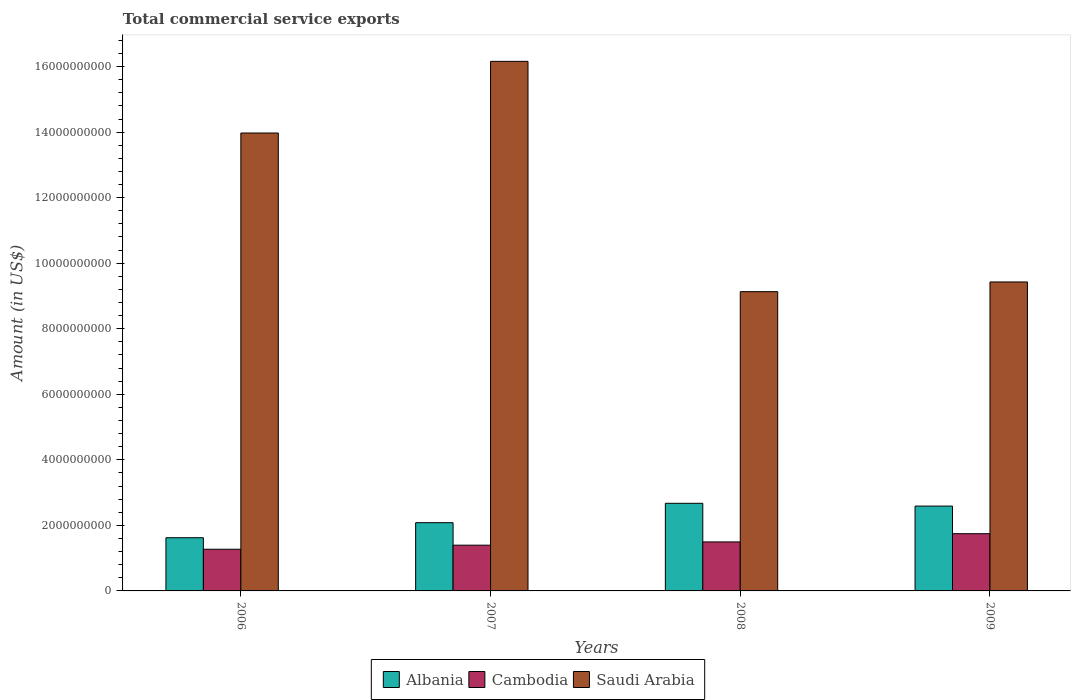Are the number of bars on each tick of the X-axis equal?
Ensure brevity in your answer.  Yes. How many bars are there on the 4th tick from the right?
Your answer should be compact. 3. What is the label of the 1st group of bars from the left?
Your response must be concise. 2006. What is the total commercial service exports in Albania in 2009?
Offer a terse response. 2.59e+09. Across all years, what is the maximum total commercial service exports in Albania?
Make the answer very short. 2.67e+09. Across all years, what is the minimum total commercial service exports in Albania?
Give a very brief answer. 1.62e+09. In which year was the total commercial service exports in Saudi Arabia minimum?
Make the answer very short. 2008. What is the total total commercial service exports in Albania in the graph?
Give a very brief answer. 8.97e+09. What is the difference between the total commercial service exports in Cambodia in 2007 and that in 2009?
Provide a short and direct response. -3.51e+08. What is the difference between the total commercial service exports in Saudi Arabia in 2008 and the total commercial service exports in Albania in 2009?
Offer a very short reply. 6.54e+09. What is the average total commercial service exports in Saudi Arabia per year?
Offer a very short reply. 1.22e+1. In the year 2006, what is the difference between the total commercial service exports in Albania and total commercial service exports in Saudi Arabia?
Your answer should be very brief. -1.24e+1. In how many years, is the total commercial service exports in Albania greater than 8400000000 US$?
Provide a succinct answer. 0. What is the ratio of the total commercial service exports in Albania in 2006 to that in 2008?
Provide a succinct answer. 0.61. What is the difference between the highest and the second highest total commercial service exports in Saudi Arabia?
Make the answer very short. 2.19e+09. What is the difference between the highest and the lowest total commercial service exports in Albania?
Ensure brevity in your answer.  1.05e+09. In how many years, is the total commercial service exports in Albania greater than the average total commercial service exports in Albania taken over all years?
Your answer should be very brief. 2. What does the 1st bar from the left in 2006 represents?
Make the answer very short. Albania. What does the 3rd bar from the right in 2008 represents?
Provide a succinct answer. Albania. Is it the case that in every year, the sum of the total commercial service exports in Albania and total commercial service exports in Cambodia is greater than the total commercial service exports in Saudi Arabia?
Your answer should be very brief. No. Are all the bars in the graph horizontal?
Provide a succinct answer. No. What is the difference between two consecutive major ticks on the Y-axis?
Keep it short and to the point. 2.00e+09. Does the graph contain any zero values?
Provide a succinct answer. No. Where does the legend appear in the graph?
Offer a terse response. Bottom center. How are the legend labels stacked?
Offer a very short reply. Horizontal. What is the title of the graph?
Give a very brief answer. Total commercial service exports. Does "Tunisia" appear as one of the legend labels in the graph?
Your response must be concise. No. What is the label or title of the X-axis?
Keep it short and to the point. Years. What is the label or title of the Y-axis?
Give a very brief answer. Amount (in US$). What is the Amount (in US$) in Albania in 2006?
Provide a short and direct response. 1.62e+09. What is the Amount (in US$) in Cambodia in 2006?
Provide a short and direct response. 1.27e+09. What is the Amount (in US$) in Saudi Arabia in 2006?
Offer a very short reply. 1.40e+1. What is the Amount (in US$) in Albania in 2007?
Give a very brief answer. 2.08e+09. What is the Amount (in US$) in Cambodia in 2007?
Provide a succinct answer. 1.40e+09. What is the Amount (in US$) of Saudi Arabia in 2007?
Your response must be concise. 1.62e+1. What is the Amount (in US$) of Albania in 2008?
Provide a short and direct response. 2.67e+09. What is the Amount (in US$) of Cambodia in 2008?
Keep it short and to the point. 1.49e+09. What is the Amount (in US$) in Saudi Arabia in 2008?
Keep it short and to the point. 9.13e+09. What is the Amount (in US$) of Albania in 2009?
Give a very brief answer. 2.59e+09. What is the Amount (in US$) of Cambodia in 2009?
Your answer should be compact. 1.75e+09. What is the Amount (in US$) in Saudi Arabia in 2009?
Your answer should be compact. 9.43e+09. Across all years, what is the maximum Amount (in US$) of Albania?
Ensure brevity in your answer.  2.67e+09. Across all years, what is the maximum Amount (in US$) of Cambodia?
Ensure brevity in your answer.  1.75e+09. Across all years, what is the maximum Amount (in US$) in Saudi Arabia?
Make the answer very short. 1.62e+1. Across all years, what is the minimum Amount (in US$) of Albania?
Keep it short and to the point. 1.62e+09. Across all years, what is the minimum Amount (in US$) in Cambodia?
Offer a terse response. 1.27e+09. Across all years, what is the minimum Amount (in US$) in Saudi Arabia?
Make the answer very short. 9.13e+09. What is the total Amount (in US$) in Albania in the graph?
Give a very brief answer. 8.97e+09. What is the total Amount (in US$) of Cambodia in the graph?
Offer a terse response. 5.91e+09. What is the total Amount (in US$) of Saudi Arabia in the graph?
Your answer should be very brief. 4.87e+1. What is the difference between the Amount (in US$) in Albania in 2006 and that in 2007?
Your response must be concise. -4.59e+08. What is the difference between the Amount (in US$) of Cambodia in 2006 and that in 2007?
Provide a succinct answer. -1.24e+08. What is the difference between the Amount (in US$) of Saudi Arabia in 2006 and that in 2007?
Your response must be concise. -2.19e+09. What is the difference between the Amount (in US$) in Albania in 2006 and that in 2008?
Provide a short and direct response. -1.05e+09. What is the difference between the Amount (in US$) of Cambodia in 2006 and that in 2008?
Your response must be concise. -2.23e+08. What is the difference between the Amount (in US$) in Saudi Arabia in 2006 and that in 2008?
Keep it short and to the point. 4.84e+09. What is the difference between the Amount (in US$) of Albania in 2006 and that in 2009?
Your answer should be very brief. -9.66e+08. What is the difference between the Amount (in US$) in Cambodia in 2006 and that in 2009?
Your response must be concise. -4.75e+08. What is the difference between the Amount (in US$) of Saudi Arabia in 2006 and that in 2009?
Give a very brief answer. 4.55e+09. What is the difference between the Amount (in US$) of Albania in 2007 and that in 2008?
Your answer should be compact. -5.91e+08. What is the difference between the Amount (in US$) of Cambodia in 2007 and that in 2008?
Your response must be concise. -9.91e+07. What is the difference between the Amount (in US$) of Saudi Arabia in 2007 and that in 2008?
Provide a short and direct response. 7.03e+09. What is the difference between the Amount (in US$) in Albania in 2007 and that in 2009?
Keep it short and to the point. -5.06e+08. What is the difference between the Amount (in US$) in Cambodia in 2007 and that in 2009?
Ensure brevity in your answer.  -3.51e+08. What is the difference between the Amount (in US$) of Saudi Arabia in 2007 and that in 2009?
Offer a very short reply. 6.73e+09. What is the difference between the Amount (in US$) in Albania in 2008 and that in 2009?
Your response must be concise. 8.51e+07. What is the difference between the Amount (in US$) of Cambodia in 2008 and that in 2009?
Ensure brevity in your answer.  -2.52e+08. What is the difference between the Amount (in US$) in Saudi Arabia in 2008 and that in 2009?
Ensure brevity in your answer.  -2.96e+08. What is the difference between the Amount (in US$) in Albania in 2006 and the Amount (in US$) in Cambodia in 2007?
Your answer should be very brief. 2.27e+08. What is the difference between the Amount (in US$) of Albania in 2006 and the Amount (in US$) of Saudi Arabia in 2007?
Ensure brevity in your answer.  -1.45e+1. What is the difference between the Amount (in US$) of Cambodia in 2006 and the Amount (in US$) of Saudi Arabia in 2007?
Offer a terse response. -1.49e+1. What is the difference between the Amount (in US$) of Albania in 2006 and the Amount (in US$) of Cambodia in 2008?
Give a very brief answer. 1.28e+08. What is the difference between the Amount (in US$) of Albania in 2006 and the Amount (in US$) of Saudi Arabia in 2008?
Your answer should be compact. -7.51e+09. What is the difference between the Amount (in US$) of Cambodia in 2006 and the Amount (in US$) of Saudi Arabia in 2008?
Make the answer very short. -7.86e+09. What is the difference between the Amount (in US$) of Albania in 2006 and the Amount (in US$) of Cambodia in 2009?
Provide a short and direct response. -1.23e+08. What is the difference between the Amount (in US$) of Albania in 2006 and the Amount (in US$) of Saudi Arabia in 2009?
Your answer should be compact. -7.80e+09. What is the difference between the Amount (in US$) in Cambodia in 2006 and the Amount (in US$) in Saudi Arabia in 2009?
Offer a terse response. -8.16e+09. What is the difference between the Amount (in US$) of Albania in 2007 and the Amount (in US$) of Cambodia in 2008?
Provide a succinct answer. 5.88e+08. What is the difference between the Amount (in US$) in Albania in 2007 and the Amount (in US$) in Saudi Arabia in 2008?
Offer a very short reply. -7.05e+09. What is the difference between the Amount (in US$) of Cambodia in 2007 and the Amount (in US$) of Saudi Arabia in 2008?
Ensure brevity in your answer.  -7.74e+09. What is the difference between the Amount (in US$) of Albania in 2007 and the Amount (in US$) of Cambodia in 2009?
Provide a short and direct response. 3.36e+08. What is the difference between the Amount (in US$) of Albania in 2007 and the Amount (in US$) of Saudi Arabia in 2009?
Your answer should be very brief. -7.35e+09. What is the difference between the Amount (in US$) in Cambodia in 2007 and the Amount (in US$) in Saudi Arabia in 2009?
Offer a terse response. -8.03e+09. What is the difference between the Amount (in US$) of Albania in 2008 and the Amount (in US$) of Cambodia in 2009?
Provide a succinct answer. 9.27e+08. What is the difference between the Amount (in US$) of Albania in 2008 and the Amount (in US$) of Saudi Arabia in 2009?
Give a very brief answer. -6.75e+09. What is the difference between the Amount (in US$) in Cambodia in 2008 and the Amount (in US$) in Saudi Arabia in 2009?
Your response must be concise. -7.93e+09. What is the average Amount (in US$) in Albania per year?
Offer a terse response. 2.24e+09. What is the average Amount (in US$) in Cambodia per year?
Offer a terse response. 1.48e+09. What is the average Amount (in US$) of Saudi Arabia per year?
Your answer should be compact. 1.22e+1. In the year 2006, what is the difference between the Amount (in US$) in Albania and Amount (in US$) in Cambodia?
Offer a very short reply. 3.51e+08. In the year 2006, what is the difference between the Amount (in US$) in Albania and Amount (in US$) in Saudi Arabia?
Your answer should be very brief. -1.24e+1. In the year 2006, what is the difference between the Amount (in US$) in Cambodia and Amount (in US$) in Saudi Arabia?
Keep it short and to the point. -1.27e+1. In the year 2007, what is the difference between the Amount (in US$) in Albania and Amount (in US$) in Cambodia?
Your response must be concise. 6.87e+08. In the year 2007, what is the difference between the Amount (in US$) in Albania and Amount (in US$) in Saudi Arabia?
Your answer should be compact. -1.41e+1. In the year 2007, what is the difference between the Amount (in US$) in Cambodia and Amount (in US$) in Saudi Arabia?
Give a very brief answer. -1.48e+1. In the year 2008, what is the difference between the Amount (in US$) in Albania and Amount (in US$) in Cambodia?
Your response must be concise. 1.18e+09. In the year 2008, what is the difference between the Amount (in US$) of Albania and Amount (in US$) of Saudi Arabia?
Offer a very short reply. -6.46e+09. In the year 2008, what is the difference between the Amount (in US$) in Cambodia and Amount (in US$) in Saudi Arabia?
Your answer should be very brief. -7.64e+09. In the year 2009, what is the difference between the Amount (in US$) in Albania and Amount (in US$) in Cambodia?
Make the answer very short. 8.42e+08. In the year 2009, what is the difference between the Amount (in US$) in Albania and Amount (in US$) in Saudi Arabia?
Your answer should be compact. -6.84e+09. In the year 2009, what is the difference between the Amount (in US$) in Cambodia and Amount (in US$) in Saudi Arabia?
Make the answer very short. -7.68e+09. What is the ratio of the Amount (in US$) of Albania in 2006 to that in 2007?
Give a very brief answer. 0.78. What is the ratio of the Amount (in US$) in Cambodia in 2006 to that in 2007?
Offer a very short reply. 0.91. What is the ratio of the Amount (in US$) in Saudi Arabia in 2006 to that in 2007?
Provide a succinct answer. 0.86. What is the ratio of the Amount (in US$) of Albania in 2006 to that in 2008?
Provide a succinct answer. 0.61. What is the ratio of the Amount (in US$) in Cambodia in 2006 to that in 2008?
Make the answer very short. 0.85. What is the ratio of the Amount (in US$) of Saudi Arabia in 2006 to that in 2008?
Keep it short and to the point. 1.53. What is the ratio of the Amount (in US$) of Albania in 2006 to that in 2009?
Your answer should be compact. 0.63. What is the ratio of the Amount (in US$) in Cambodia in 2006 to that in 2009?
Your answer should be very brief. 0.73. What is the ratio of the Amount (in US$) in Saudi Arabia in 2006 to that in 2009?
Your response must be concise. 1.48. What is the ratio of the Amount (in US$) of Albania in 2007 to that in 2008?
Ensure brevity in your answer.  0.78. What is the ratio of the Amount (in US$) of Cambodia in 2007 to that in 2008?
Your answer should be compact. 0.93. What is the ratio of the Amount (in US$) of Saudi Arabia in 2007 to that in 2008?
Offer a terse response. 1.77. What is the ratio of the Amount (in US$) in Albania in 2007 to that in 2009?
Your answer should be very brief. 0.8. What is the ratio of the Amount (in US$) in Cambodia in 2007 to that in 2009?
Ensure brevity in your answer.  0.8. What is the ratio of the Amount (in US$) in Saudi Arabia in 2007 to that in 2009?
Your answer should be very brief. 1.71. What is the ratio of the Amount (in US$) in Albania in 2008 to that in 2009?
Your answer should be very brief. 1.03. What is the ratio of the Amount (in US$) of Cambodia in 2008 to that in 2009?
Offer a very short reply. 0.86. What is the ratio of the Amount (in US$) of Saudi Arabia in 2008 to that in 2009?
Keep it short and to the point. 0.97. What is the difference between the highest and the second highest Amount (in US$) of Albania?
Your answer should be compact. 8.51e+07. What is the difference between the highest and the second highest Amount (in US$) in Cambodia?
Offer a very short reply. 2.52e+08. What is the difference between the highest and the second highest Amount (in US$) of Saudi Arabia?
Offer a very short reply. 2.19e+09. What is the difference between the highest and the lowest Amount (in US$) in Albania?
Ensure brevity in your answer.  1.05e+09. What is the difference between the highest and the lowest Amount (in US$) of Cambodia?
Ensure brevity in your answer.  4.75e+08. What is the difference between the highest and the lowest Amount (in US$) of Saudi Arabia?
Provide a short and direct response. 7.03e+09. 